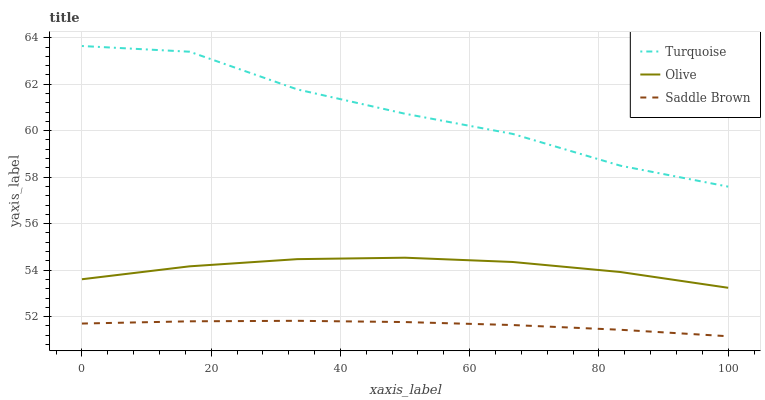Does Saddle Brown have the minimum area under the curve?
Answer yes or no. Yes. Does Turquoise have the maximum area under the curve?
Answer yes or no. Yes. Does Turquoise have the minimum area under the curve?
Answer yes or no. No. Does Saddle Brown have the maximum area under the curve?
Answer yes or no. No. Is Saddle Brown the smoothest?
Answer yes or no. Yes. Is Turquoise the roughest?
Answer yes or no. Yes. Is Turquoise the smoothest?
Answer yes or no. No. Is Saddle Brown the roughest?
Answer yes or no. No. Does Saddle Brown have the lowest value?
Answer yes or no. Yes. Does Turquoise have the lowest value?
Answer yes or no. No. Does Turquoise have the highest value?
Answer yes or no. Yes. Does Saddle Brown have the highest value?
Answer yes or no. No. Is Olive less than Turquoise?
Answer yes or no. Yes. Is Turquoise greater than Saddle Brown?
Answer yes or no. Yes. Does Olive intersect Turquoise?
Answer yes or no. No. 